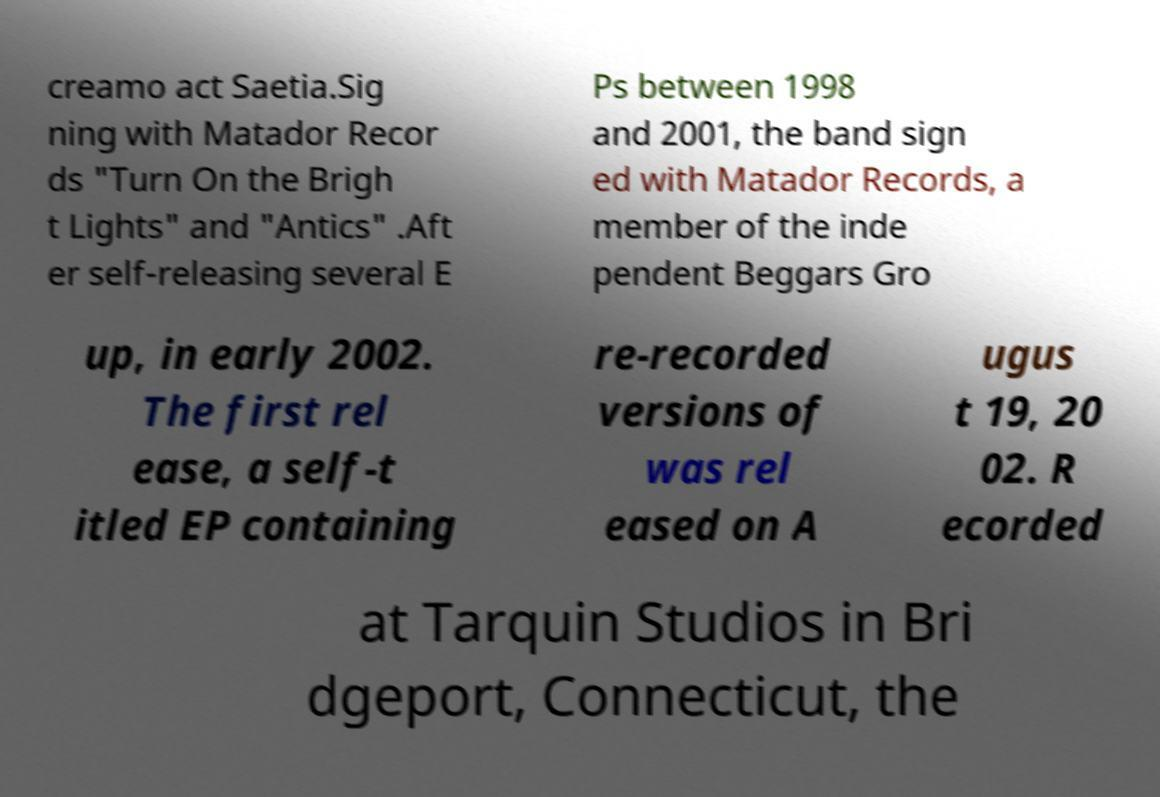Could you extract and type out the text from this image? creamo act Saetia.Sig ning with Matador Recor ds "Turn On the Brigh t Lights" and "Antics" .Aft er self-releasing several E Ps between 1998 and 2001, the band sign ed with Matador Records, a member of the inde pendent Beggars Gro up, in early 2002. The first rel ease, a self-t itled EP containing re-recorded versions of was rel eased on A ugus t 19, 20 02. R ecorded at Tarquin Studios in Bri dgeport, Connecticut, the 